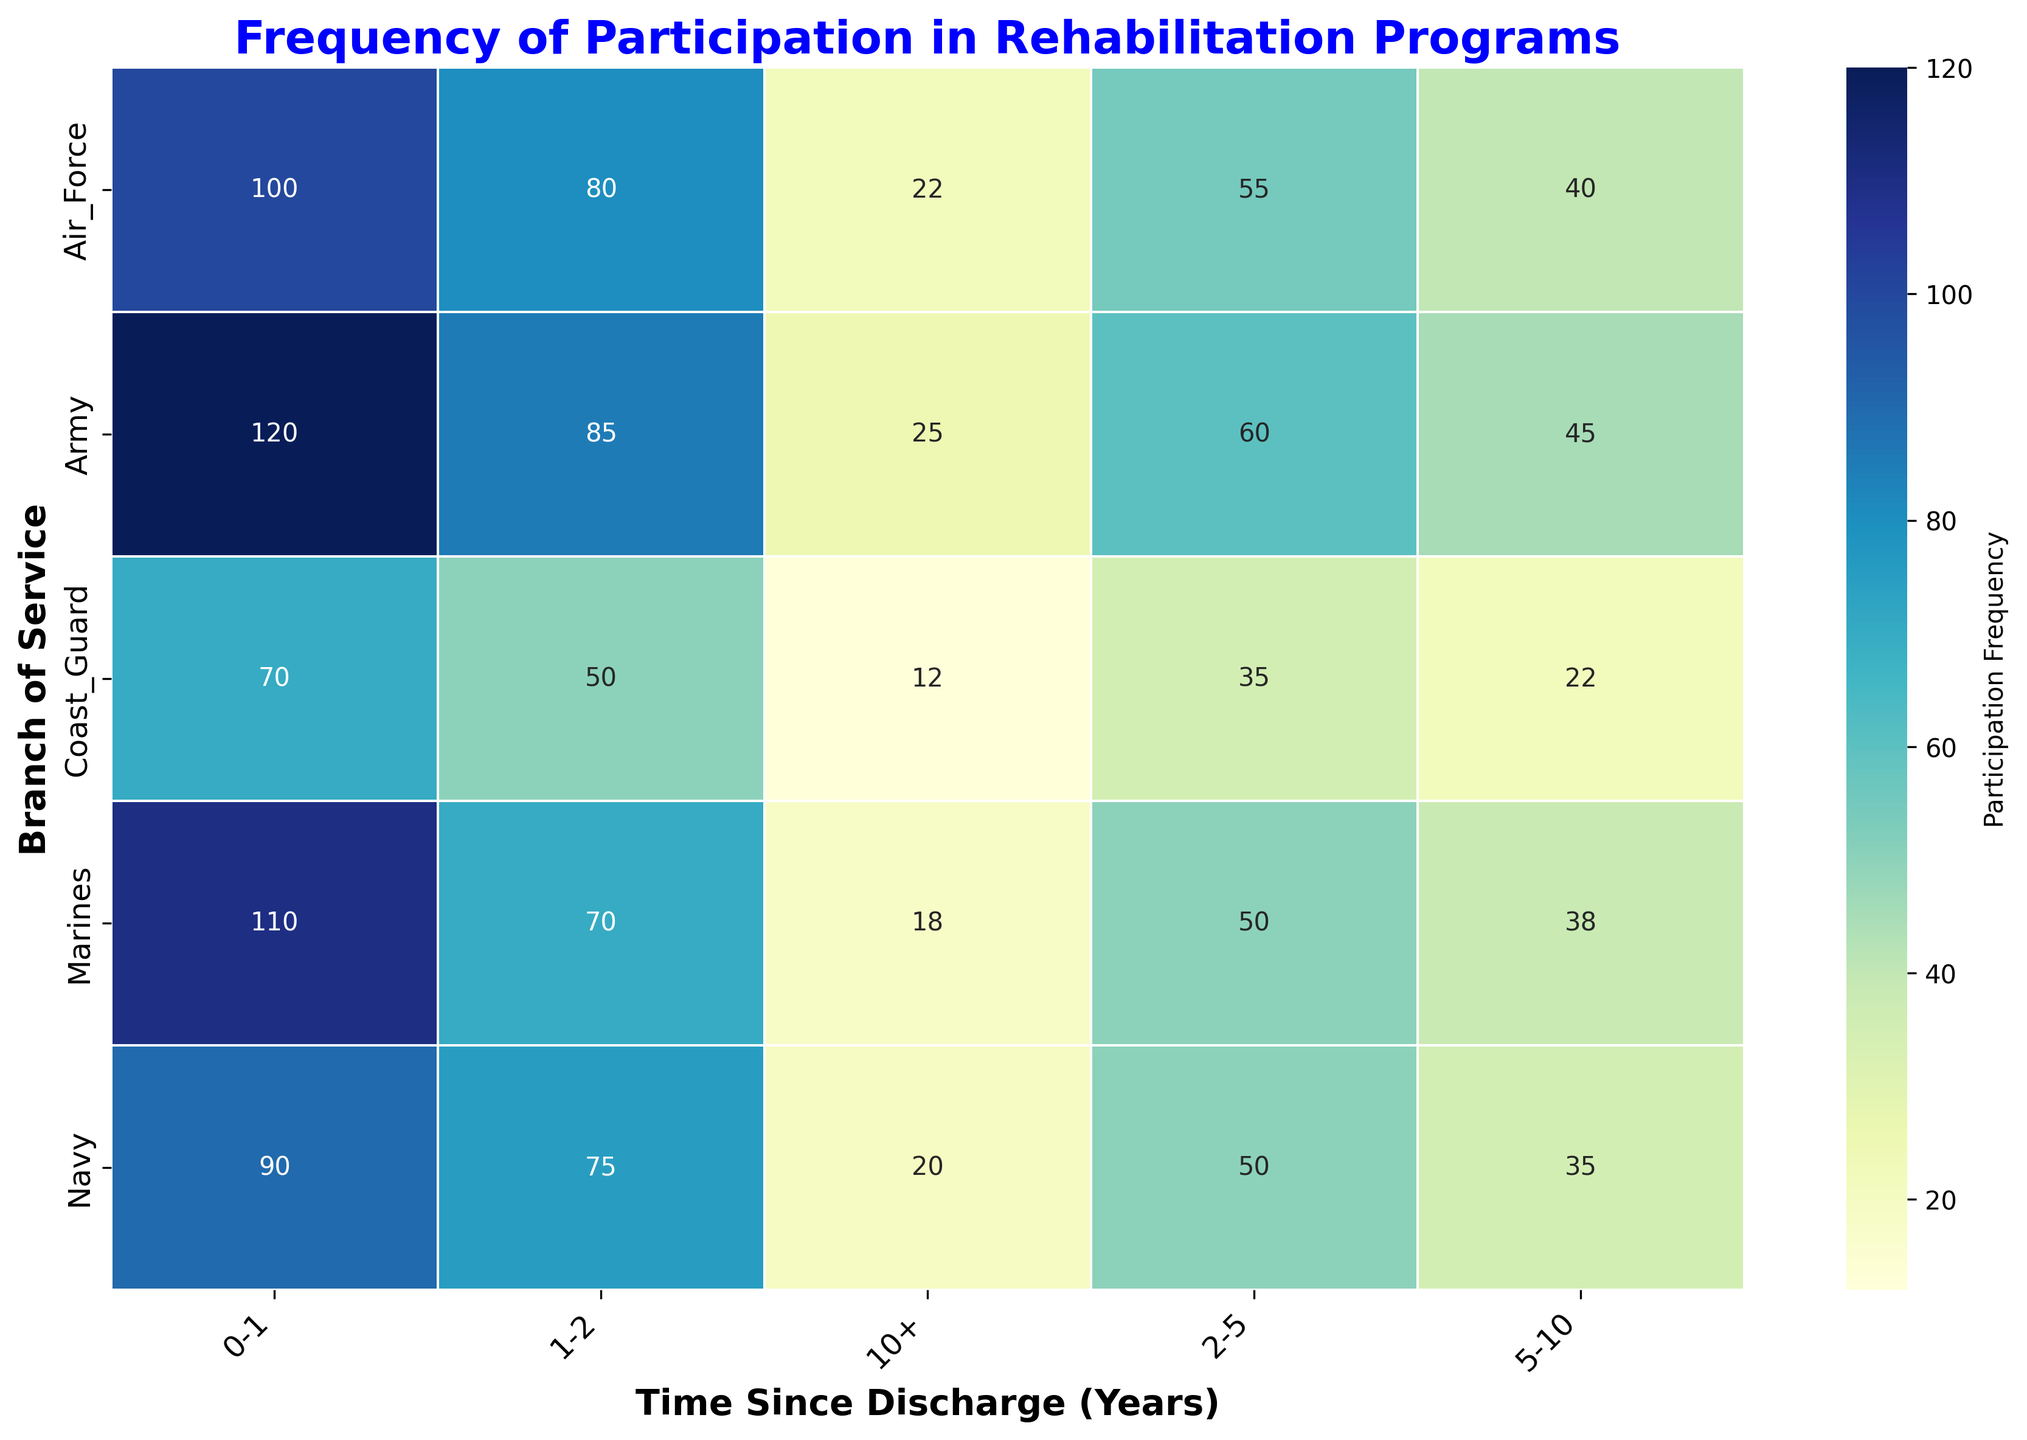What is the frequency of participation for Army members who have been discharged for 0-1 years? Look at the value in the cell where the 'Army' row intersects with the '0-1' column. The number is directly written in the cell.
Answer: 120 Which branch has the highest frequency of participation in rehabilitation programs for the 1-2 year discharge group? Compare the values in the '1-2' column for each branch. The branch with the highest number is the one you're looking for.
Answer: Army What is the total frequency of participation for the Air Force across all time since discharge groups? Sum the values across the 'Air_Force' row. This includes (100 + 80 + 55 + 40 + 22). Perform the addition: 100 + 80 = 180, 180 + 55 = 235, 235 + 40 = 275, 275 + 22 = 297.
Answer: 297 Compare the frequency of participation between the Army and the Navy for the 2-5 year discharge group. Which one is higher? Examine the 'Army' and 'Navy' rows in the '2-5' column. Army has 60, and Navy has 50. Army's value is higher.
Answer: Army What is the average frequency of participation across all branches for the 5-10 year discharge group? Add the values in the '5-10' column for all branches and divide by the number of branches (5). The values are 45, 35, 40, 38, 22. Calculate the sum: 45 + 35 = 80, 80 + 40 = 120, 120 + 38 = 158, 158 + 22 = 180. Now divide the sum by the number of branches: 180 / 5 = 36.
Answer: 36 Which two time since discharge groups have the highest difference in participation frequency for the Marines? Identify the values for all time groups in the 'Marines' row: 0-1 (110), 1-2 (70), 2-5 (50), 5-10 (38), 10+ (18). The highest difference is between 0-1 and 10+: 110 - 18 = 92.
Answer: 0-1 and 10+ What is the lowest frequency of participation for the Coast Guard? Look across the 'Coast_Guard' row to find the smallest number. The values are 70, 50, 35, 22, 12. The smallest value is 12.
Answer: 12 Compare the frequency of participation for the Air Force and Marines for the 0-1 year discharge group. Are they equal? Check the values in the '0-1' column for 'Air_Force' and 'Marines'. Air Force has 100, and Marines has 110. They are not equal.
Answer: No For which branch is the decline in participation frequency most consistent as time since discharge increases? Observe each branch row and see how the numbers decrease across columns. The Coast Guard shows a consistent decline: 70, 50, 35, 22, 12.
Answer: Coast Guard 